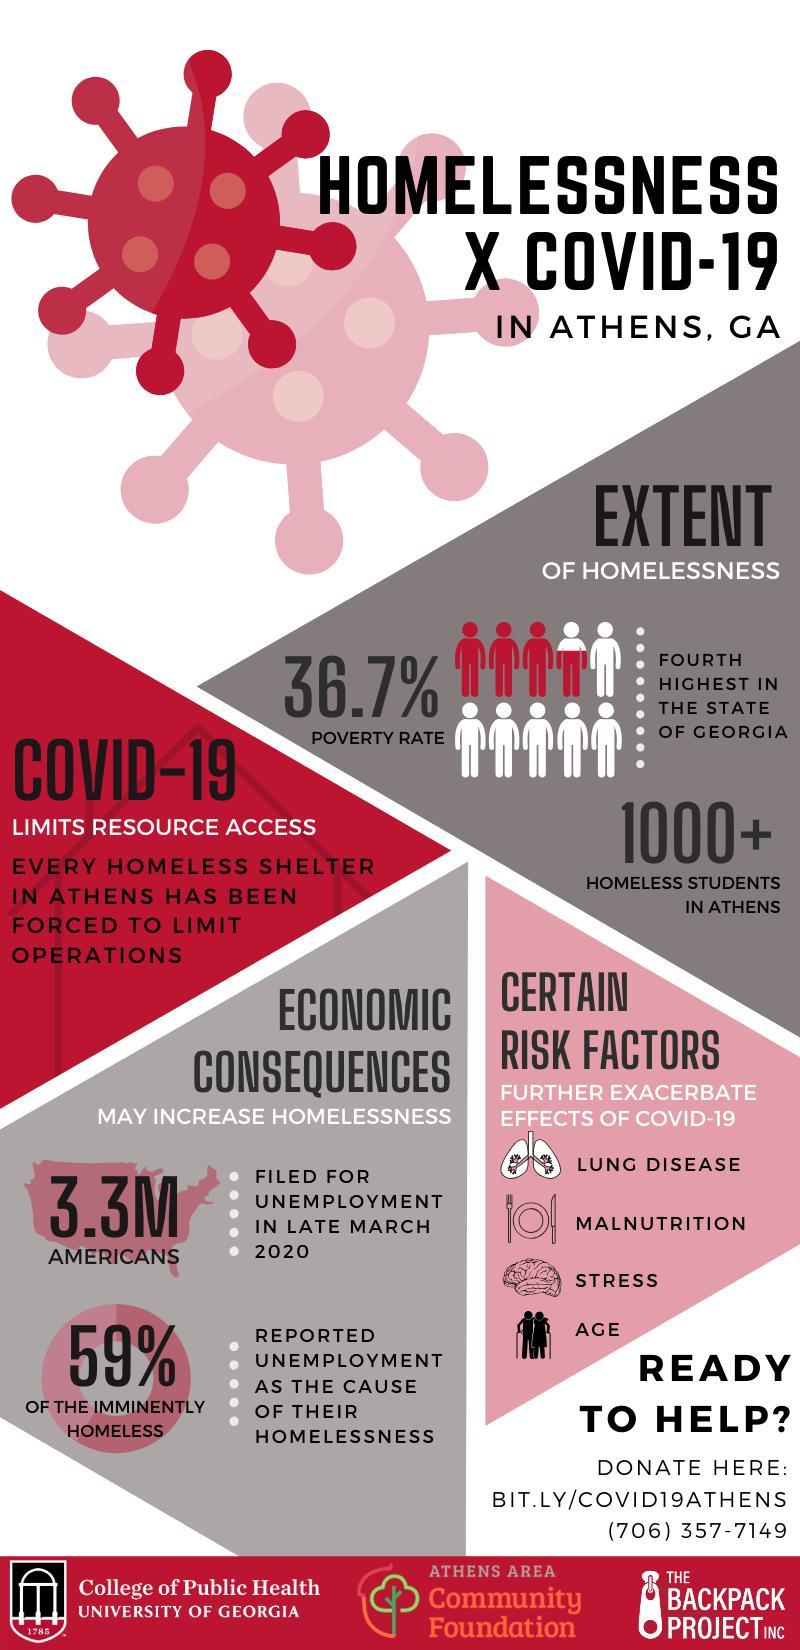How many Americans were unemployed in late March 2020?
Answer the question with a short phrase. 3.3M What percent of Americans reported unemployment as the cause of their homelessness? 59% What are certain risk factors that further increase the effects of COVID-19 other than stress & age? LUNG DISEASE, MALNUTRITION 